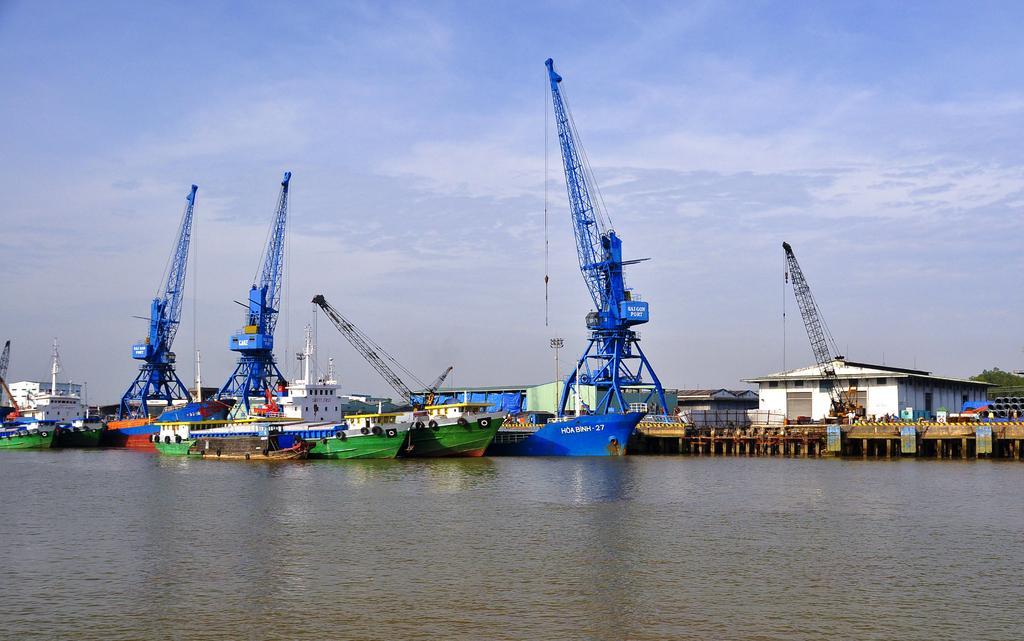In one or two sentences, can you explain what this image depicts? In the image there is a shipyard, there are many ships beside the bridge on a water surface. On the bridge there are few compartments. 